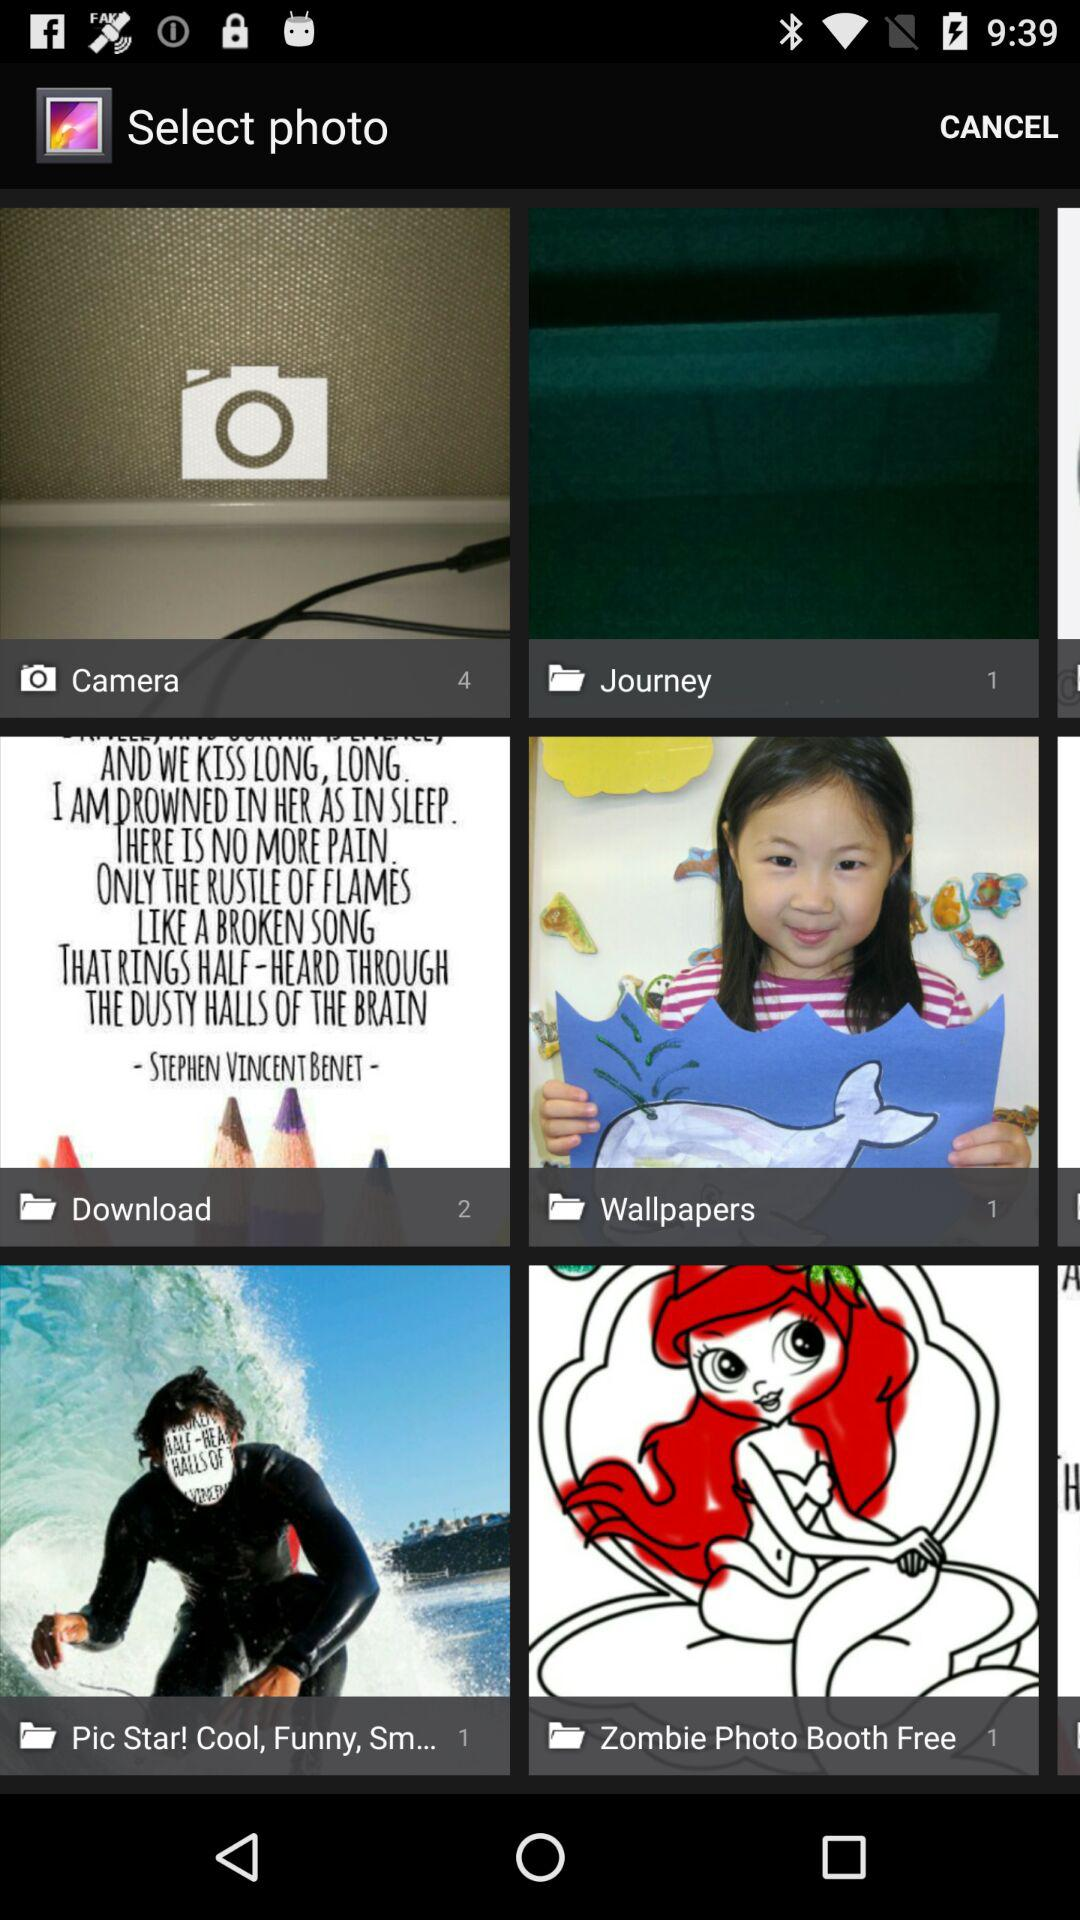How many photos are there in the "Camera" folder? There are 4 photos. 